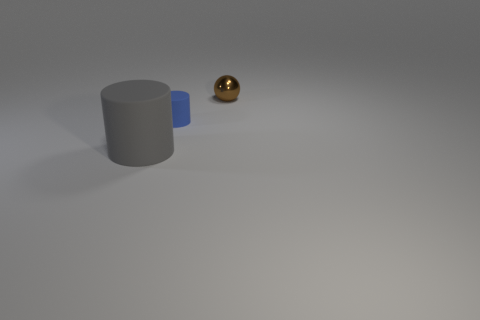How many brown objects are either shiny spheres or tiny objects?
Make the answer very short. 1. There is a large rubber object; what number of gray rubber cylinders are right of it?
Offer a terse response. 0. There is a object behind the tiny thing in front of the small thing behind the blue matte cylinder; how big is it?
Offer a terse response. Small. Is there a big gray matte thing to the right of the cylinder on the left side of the matte object on the right side of the gray rubber cylinder?
Your answer should be very brief. No. Is the number of small green shiny cylinders greater than the number of small metallic objects?
Make the answer very short. No. There is a cylinder that is behind the gray rubber thing; what is its color?
Offer a very short reply. Blue. Is the number of blue things behind the small metallic ball greater than the number of gray objects?
Make the answer very short. No. Do the brown object and the gray cylinder have the same material?
Your answer should be compact. No. How many other things are there of the same shape as the brown shiny thing?
Provide a succinct answer. 0. Is there anything else that has the same material as the big object?
Provide a succinct answer. Yes. 